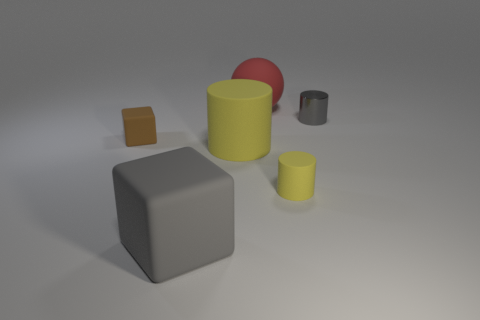What material is the object to the left of the large gray block?
Keep it short and to the point. Rubber. Are there any other things that have the same material as the gray cylinder?
Your answer should be very brief. No. What material is the large thing that is the same shape as the small shiny thing?
Keep it short and to the point. Rubber. There is a matte thing that is both behind the large yellow rubber cylinder and on the right side of the large yellow cylinder; what is its size?
Offer a very short reply. Large. Is there anything else that is the same color as the big rubber ball?
Give a very brief answer. No. How big is the gray object that is to the left of the small cylinder that is behind the brown block?
Your answer should be very brief. Large. There is a small object that is both on the left side of the shiny object and behind the small rubber cylinder; what is its color?
Offer a very short reply. Brown. What number of other objects are the same size as the metal thing?
Make the answer very short. 2. There is a red thing; is its size the same as the yellow cylinder in front of the large yellow cylinder?
Offer a terse response. No. There is a block that is the same size as the gray cylinder; what is its color?
Provide a short and direct response. Brown. 